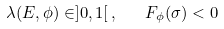<formula> <loc_0><loc_0><loc_500><loc_500>\lambda ( E , \phi ) \in ] 0 , 1 [ \, , \quad F _ { \phi } ( \sigma ) < 0</formula> 